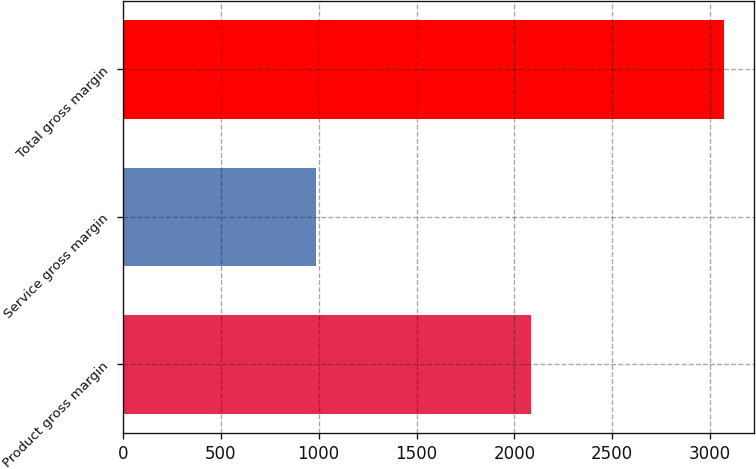Convert chart to OTSL. <chart><loc_0><loc_0><loc_500><loc_500><bar_chart><fcel>Product gross margin<fcel>Service gross margin<fcel>Total gross margin<nl><fcel>2085.3<fcel>986.8<fcel>3072.1<nl></chart> 